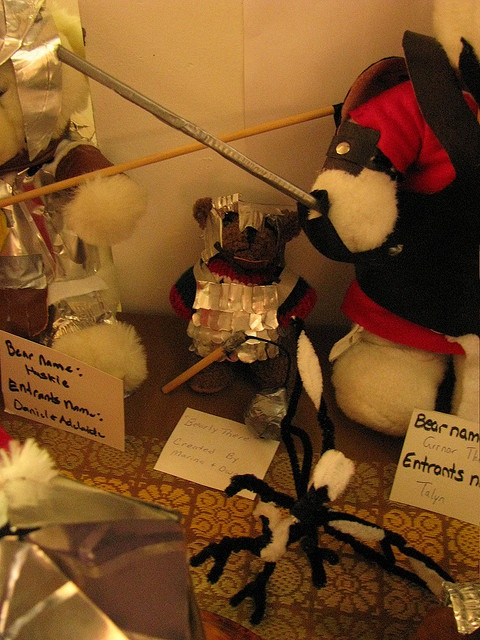Describe the objects in this image and their specific colors. I can see teddy bear in tan, black, olive, and maroon tones, teddy bear in tan, olive, maroon, and black tones, and teddy bear in tan, black, olive, and maroon tones in this image. 